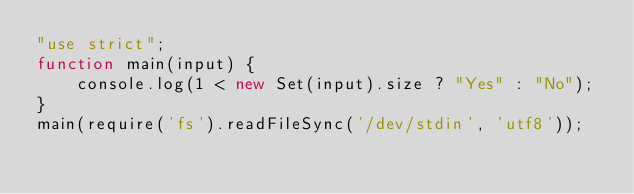Convert code to text. <code><loc_0><loc_0><loc_500><loc_500><_JavaScript_>"use strict";
function main(input) {
    console.log(1 < new Set(input).size ? "Yes" : "No");
}
main(require('fs').readFileSync('/dev/stdin', 'utf8'));</code> 